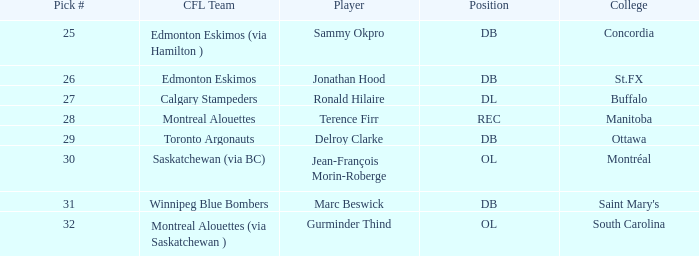Which CFL Team has a Pick # larger than 31? Montreal Alouettes (via Saskatchewan ). 